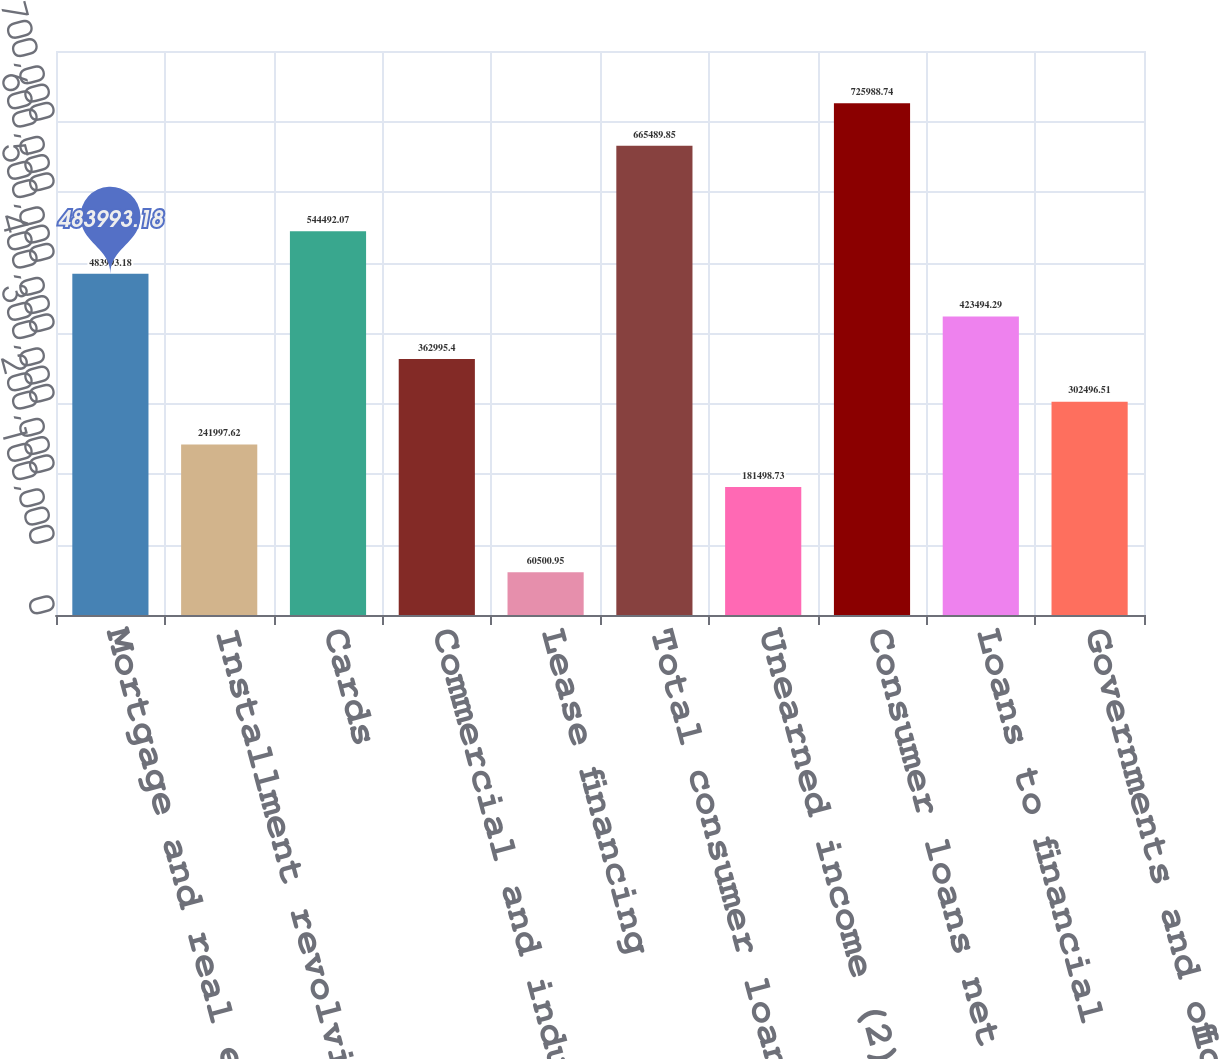Convert chart to OTSL. <chart><loc_0><loc_0><loc_500><loc_500><bar_chart><fcel>Mortgage and real estate (1)<fcel>Installment revolving credit<fcel>Cards<fcel>Commercial and industrial<fcel>Lease financing<fcel>Total consumer loans<fcel>Unearned income (2)<fcel>Consumer loans net of unearned<fcel>Loans to financial<fcel>Governments and official<nl><fcel>483993<fcel>241998<fcel>544492<fcel>362995<fcel>60500.9<fcel>665490<fcel>181499<fcel>725989<fcel>423494<fcel>302497<nl></chart> 